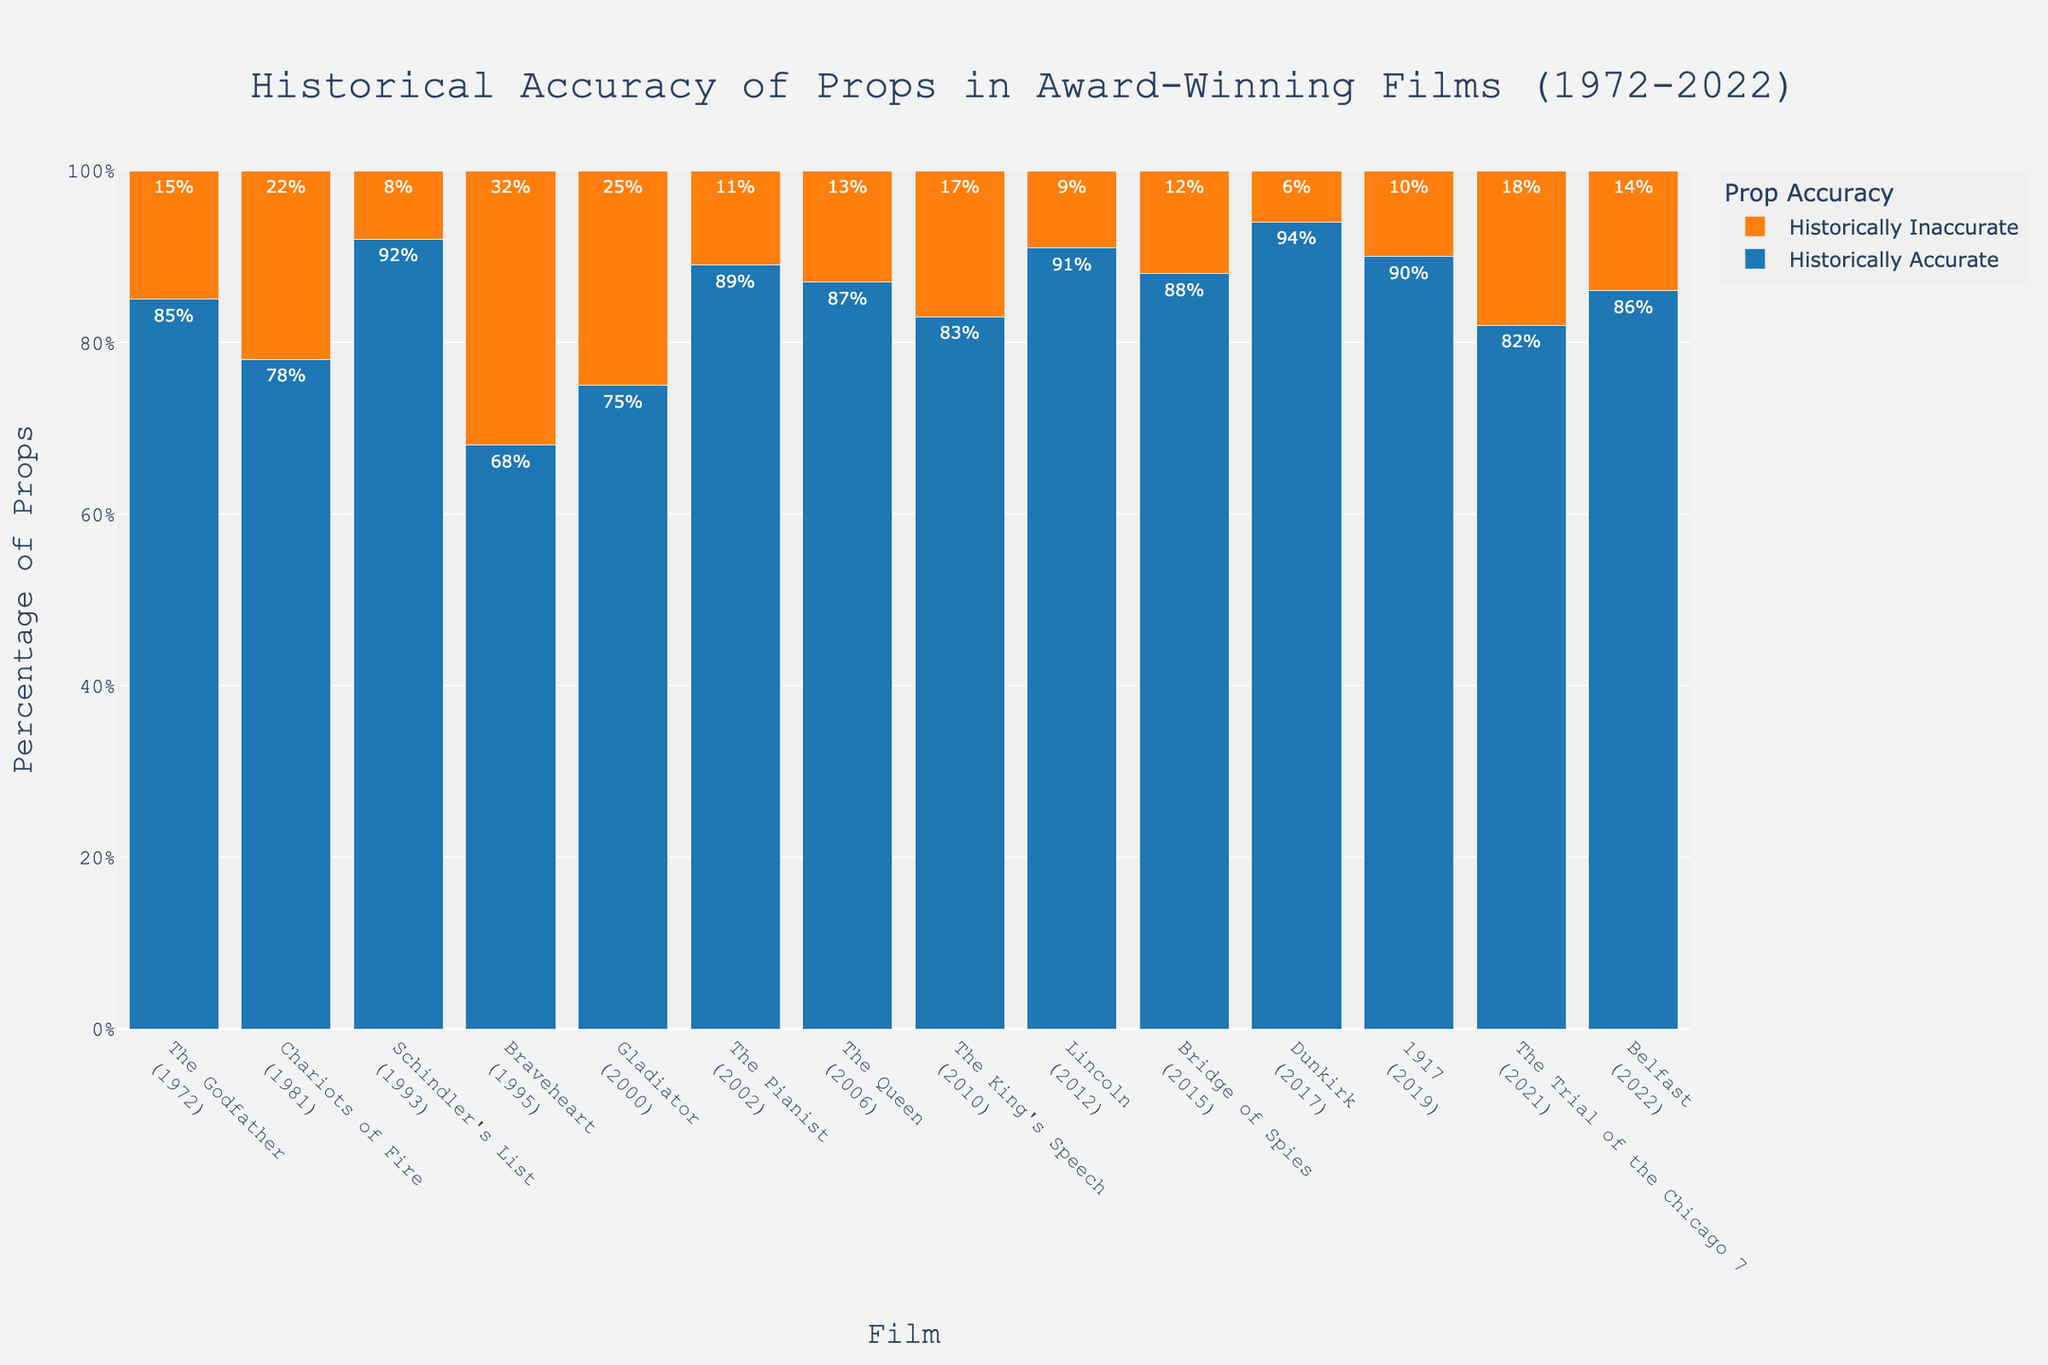Which film has the highest percentage of historically accurate props? To find the film with the highest percentage of historically accurate props, look for the tallest blue bar in the chart. Dunkirk has the highest percentage of historically accurate props at 94%.
Answer: Dunkirk Which film has the largest discrepancy between historically accurate and inaccurate props? The largest discrepancy is seen by observing the biggest difference in bar heights between blue (accurate) and orange (inaccurate) bars. Braveheart has a difference of 68% - 32% = 36%.
Answer: Braveheart Which two consecutive films have the most significant increase in historically accurate props? Compare the height of the blue bars for consecutive films. The most significant increase occurs between Braveheart (68%) and Schindler's List (92%), which is an increase of 24%.
Answer: Braveheart to Schindler's List Which film between 2000 and 2010 has the highest historically accurate props percentage? Look at the blue bars for films released between 2000 and 2010. The Pianist, released in 2002, has the highest percentage at 89%.
Answer: The Pianist What is the average percentage of historically accurate props for the films released after 2010? Consider films from 2012, 2015, 2017, 2019, 2021, and 2022. Calculate the average: (91 + 88 + 94 + 90 + 82 + 86) / 6 = 88.5%.
Answer: 88.5% Which film has the closest balance between historically accurate and inaccurate props? Look for a film where the blue and orange bars are almost equal. Braveheart has 68% accurate and 32% inaccurate, showing the closest balance.
Answer: Braveheart How does the percentage of historically accurate props in The Godfather compare to that in Lincoln? Compare the height of blue bars for The Godfather (85%) and Lincoln (91%). Lincoln has a higher percentage by 6%.
Answer: Lincoln is higher by 6% Which film has the least percentage of historically inaccurate props? Identify the shortest orange bar in the chart. Dunkirk has the lowest percentage of historically inaccurate props at 6%.
Answer: Dunkirk What is the total percentage of historically accurate props used in 2010 and 2012 films combined? Add the percentages for The King's Speech (83%) and Lincoln (91%) to get the total: 83 + 91 = 174%.
Answer: 174% Compare the historically accurate props percentage of The Queen with The Trial of the Chicago 7. Check the blue bars for The Queen (87%) and The Trial of the Chicago 7 (82%). The Queen has a higher percentage by 5%.
Answer: The Queen is higher by 5% 